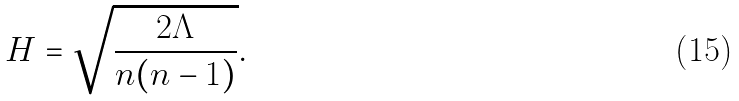<formula> <loc_0><loc_0><loc_500><loc_500>H = \sqrt { \frac { 2 \Lambda } { n ( n - 1 ) } } .</formula> 